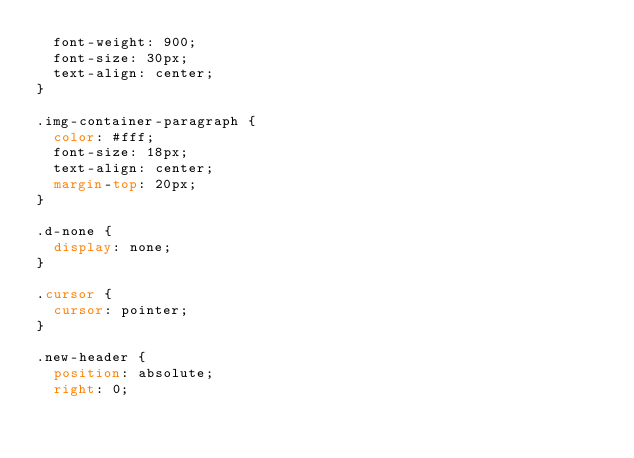<code> <loc_0><loc_0><loc_500><loc_500><_CSS_>  font-weight: 900;
  font-size: 30px;
  text-align: center;
}

.img-container-paragraph {
  color: #fff;
  font-size: 18px;
  text-align: center;
  margin-top: 20px;
}

.d-none {
  display: none;
}

.cursor {
  cursor: pointer;
}

.new-header {
  position: absolute;
  right: 0;</code> 